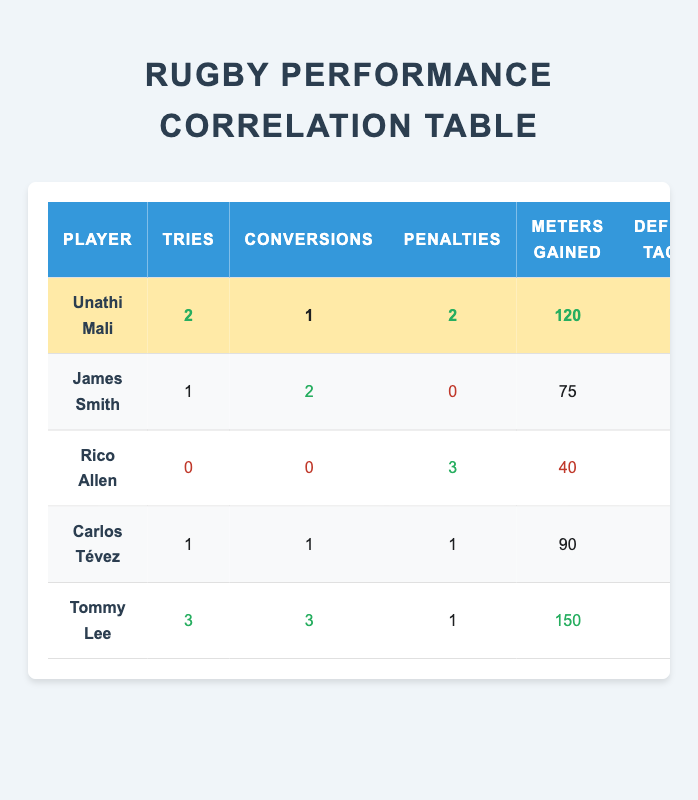What is the highest number of tries scored by any player in the match? By examining the "Tries" column, Unathi Mali scored 2, Tommy Lee scored 3, James Smith scored 1, Rico Allen scored 0, and Carlos Tévez scored 1. The maximum value among these is 3.
Answer: 3 How many conversions did Unathi Mali achieve in the match? From the table, Unathi Mali's "Conversions" column shows that he achieved 1 conversion in the match.
Answer: 1 Did Rico Allen earn any yellow cards? Looking at the "Yellow Cards" column for Rico Allen, it shows a value of 0, indicating he did not receive any yellow cards.
Answer: No What is the total number of penalties awarded by all players? To find the total penalties, we add up the values from the "Penalties" column: (2 + 0 + 3 + 1 + 1) = 7.
Answer: 7 Who had the highest meters gained and what was the value? By examining the "Meters Gained" column, Tommy Lee has the highest value at 150 meters gained, compared to others who gained less.
Answer: 150 What is the average number of defensive tackles among all players? To calculate the average, add the defensive tackles: (5 + 3 + 2 + 4 + 6) = 20. Then divide by the number of players, which is 5: 20 / 5 = 4.
Answer: 4 Did any player score more penalties than tries? By examining the "Tries" and "Penalties" columns, Rico Allen scored 0 tries and 3 penalties, and Unathi Mali scored 2 tries and 2 penalties, indicating Rico Allen had more penalties than tries.
Answer: Yes How many players scored more than one try? Checking the "Tries" column, only Tommy Lee (3 tries) scored more than 1, while Unathi Mali (2 tries) also qualifies. The total is therefore 2 players.
Answer: 2 What is the difference in meters gained between Unathi Mali and James Smith? Unathi Mali gained 120 meters while James Smith gained 75 meters. The difference is calculated as 120 - 75 = 45 meters.
Answer: 45 